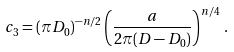<formula> <loc_0><loc_0><loc_500><loc_500>c _ { 3 } & = ( \pi D _ { 0 } ) ^ { - n / 2 } \left ( \frac { a } { 2 \pi ( D - D _ { 0 } ) } \right ) ^ { n / 4 } \, .</formula> 